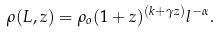Convert formula to latex. <formula><loc_0><loc_0><loc_500><loc_500>\rho ( L , z ) = \rho _ { o } ( 1 + z ) ^ { ( k + \gamma z ) } l ^ { - \alpha } .</formula> 